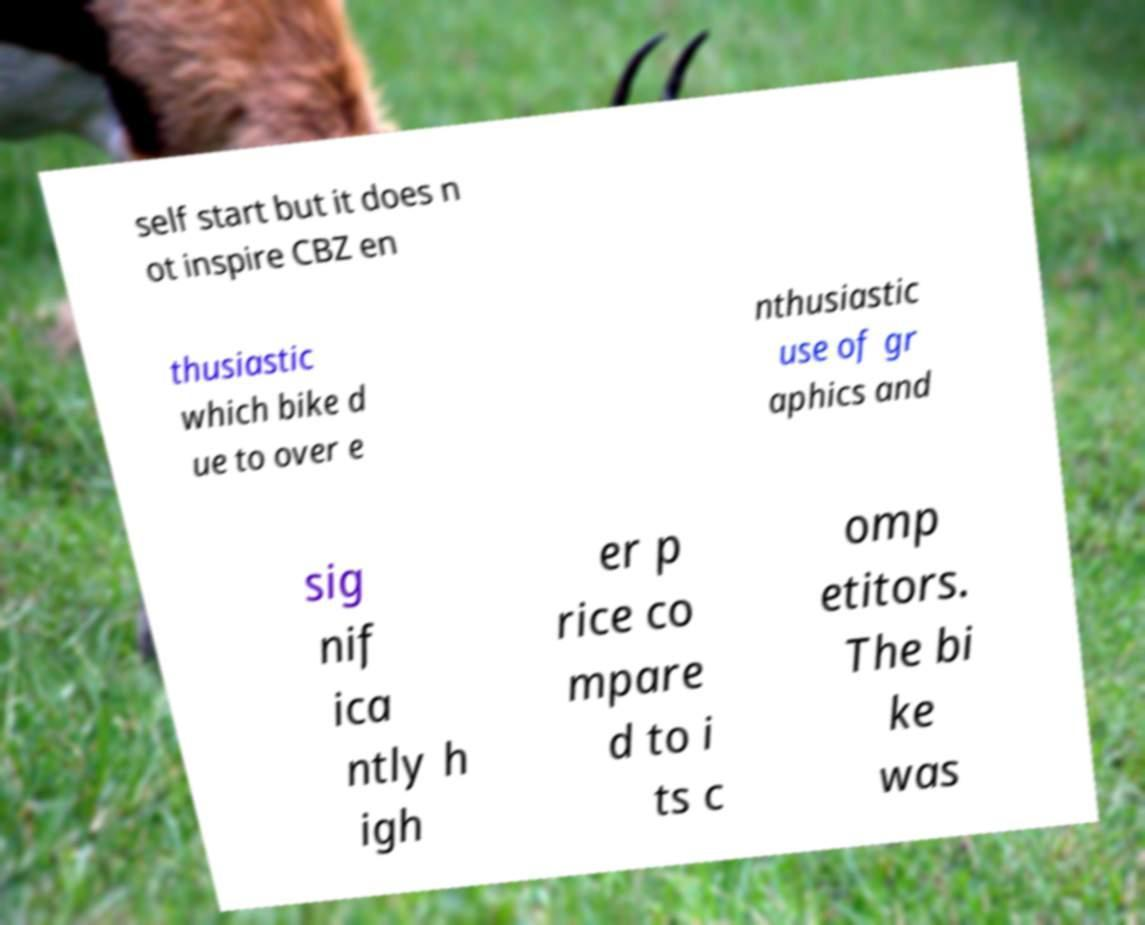There's text embedded in this image that I need extracted. Can you transcribe it verbatim? self start but it does n ot inspire CBZ en thusiastic which bike d ue to over e nthusiastic use of gr aphics and sig nif ica ntly h igh er p rice co mpare d to i ts c omp etitors. The bi ke was 